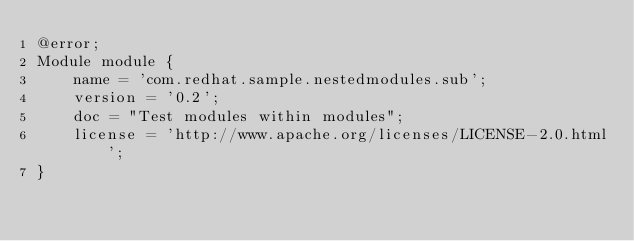<code> <loc_0><loc_0><loc_500><loc_500><_Ceylon_>@error;
Module module {
    name = 'com.redhat.sample.nestedmodules.sub';
    version = '0.2';
    doc = "Test modules within modules";
    license = 'http://www.apache.org/licenses/LICENSE-2.0.html';
}</code> 